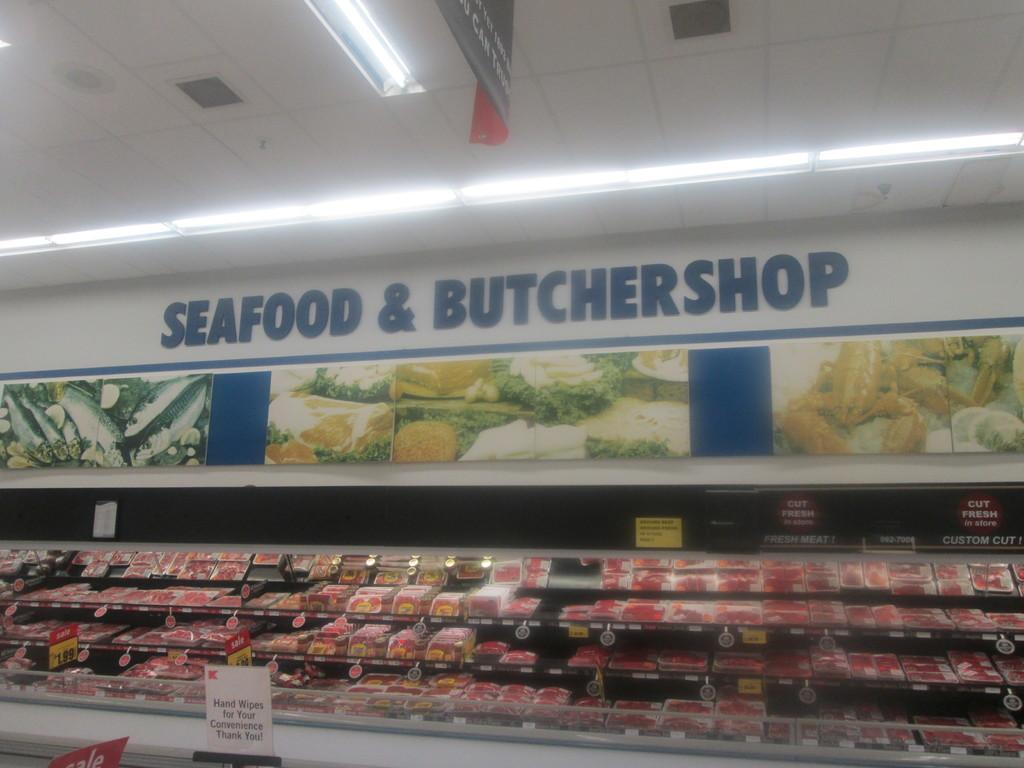Provide a one-sentence caption for the provided image. The shelves of a seafood butchershop and all of the meat there. 